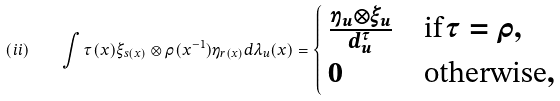Convert formula to latex. <formula><loc_0><loc_0><loc_500><loc_500>( i i ) \quad \int \tau ( x ) \xi _ { s ( x ) } \otimes \rho ( x ^ { - 1 } ) \eta _ { r ( x ) } d \lambda _ { u } ( x ) = \begin{cases} \, \frac { \eta _ { u } \otimes \xi _ { u } } { d _ { u } ^ { \tau } } & \text {if} \, \tau = \rho , \\ \, 0 & \text {otherwise} , \end{cases}</formula> 